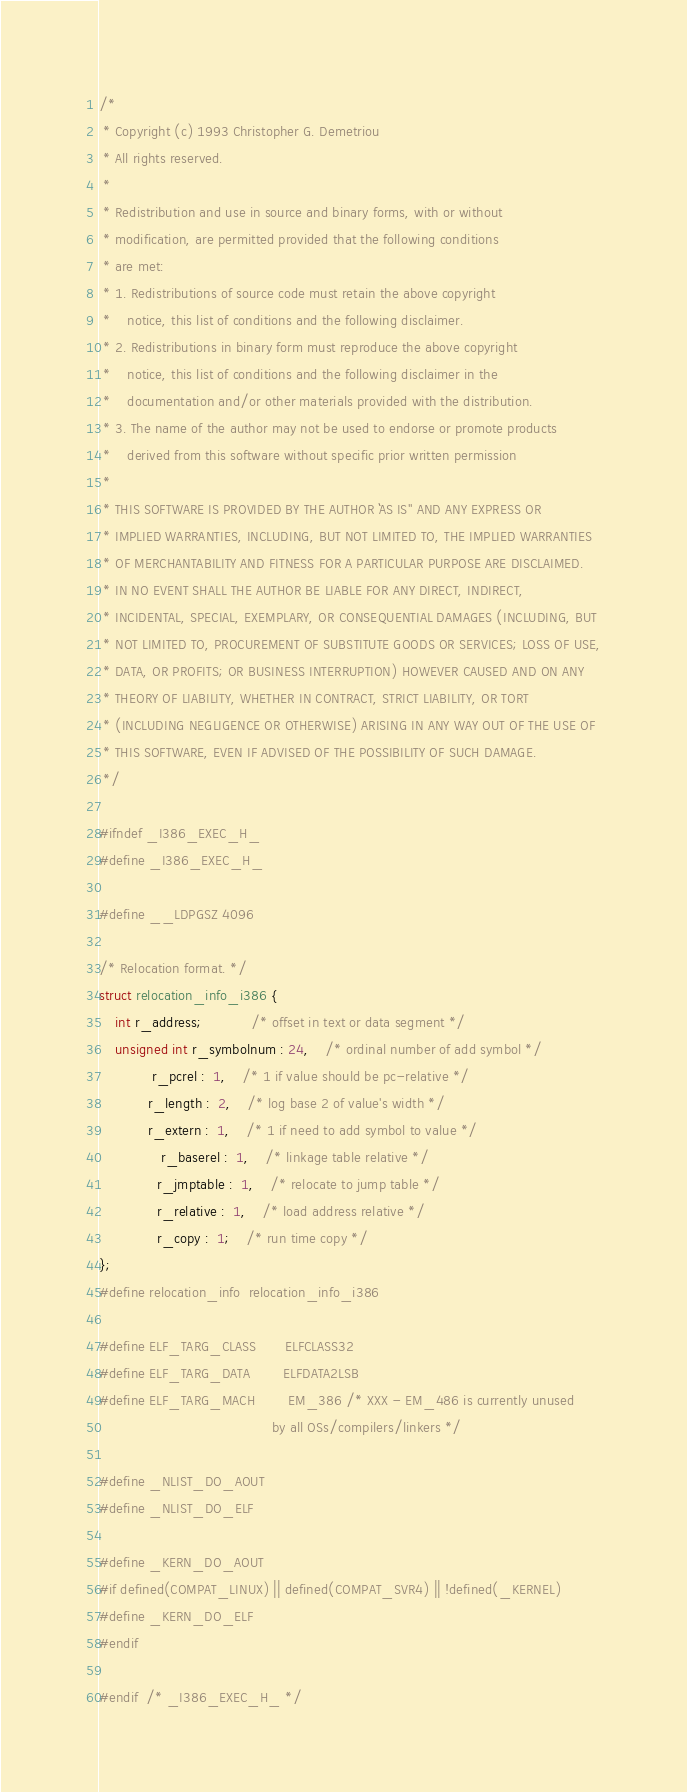<code> <loc_0><loc_0><loc_500><loc_500><_C_>/*
 * Copyright (c) 1993 Christopher G. Demetriou
 * All rights reserved.
 *
 * Redistribution and use in source and binary forms, with or without
 * modification, are permitted provided that the following conditions
 * are met:
 * 1. Redistributions of source code must retain the above copyright
 *    notice, this list of conditions and the following disclaimer.
 * 2. Redistributions in binary form must reproduce the above copyright
 *    notice, this list of conditions and the following disclaimer in the
 *    documentation and/or other materials provided with the distribution.
 * 3. The name of the author may not be used to endorse or promote products
 *    derived from this software without specific prior written permission
 *
 * THIS SOFTWARE IS PROVIDED BY THE AUTHOR ``AS IS'' AND ANY EXPRESS OR
 * IMPLIED WARRANTIES, INCLUDING, BUT NOT LIMITED TO, THE IMPLIED WARRANTIES
 * OF MERCHANTABILITY AND FITNESS FOR A PARTICULAR PURPOSE ARE DISCLAIMED.
 * IN NO EVENT SHALL THE AUTHOR BE LIABLE FOR ANY DIRECT, INDIRECT,
 * INCIDENTAL, SPECIAL, EXEMPLARY, OR CONSEQUENTIAL DAMAGES (INCLUDING, BUT
 * NOT LIMITED TO, PROCUREMENT OF SUBSTITUTE GOODS OR SERVICES; LOSS OF USE,
 * DATA, OR PROFITS; OR BUSINESS INTERRUPTION) HOWEVER CAUSED AND ON ANY
 * THEORY OF LIABILITY, WHETHER IN CONTRACT, STRICT LIABILITY, OR TORT
 * (INCLUDING NEGLIGENCE OR OTHERWISE) ARISING IN ANY WAY OUT OF THE USE OF
 * THIS SOFTWARE, EVEN IF ADVISED OF THE POSSIBILITY OF SUCH DAMAGE.
 */

#ifndef _I386_EXEC_H_
#define _I386_EXEC_H_

#define __LDPGSZ	4096

/* Relocation format. */
struct relocation_info_i386 {
	int r_address;			/* offset in text or data segment */
	unsigned int r_symbolnum : 24,	/* ordinal number of add symbol */
			 r_pcrel :  1,	/* 1 if value should be pc-relative */
			r_length :  2,	/* log base 2 of value's width */
			r_extern :  1,	/* 1 if need to add symbol to value */
		       r_baserel :  1,	/* linkage table relative */
		      r_jmptable :  1,	/* relocate to jump table */
		      r_relative :  1,	/* load address relative */
			  r_copy :  1;	/* run time copy */
};
#define relocation_info	relocation_info_i386

#define ELF_TARG_CLASS		ELFCLASS32
#define ELF_TARG_DATA		ELFDATA2LSB
#define ELF_TARG_MACH		EM_386 /* XXX - EM_486 is currently unused
                                          by all OSs/compilers/linkers */

#define _NLIST_DO_AOUT
#define _NLIST_DO_ELF

#define _KERN_DO_AOUT
#if defined(COMPAT_LINUX) || defined(COMPAT_SVR4) || !defined(_KERNEL)
#define _KERN_DO_ELF
#endif

#endif  /* _I386_EXEC_H_ */
</code> 